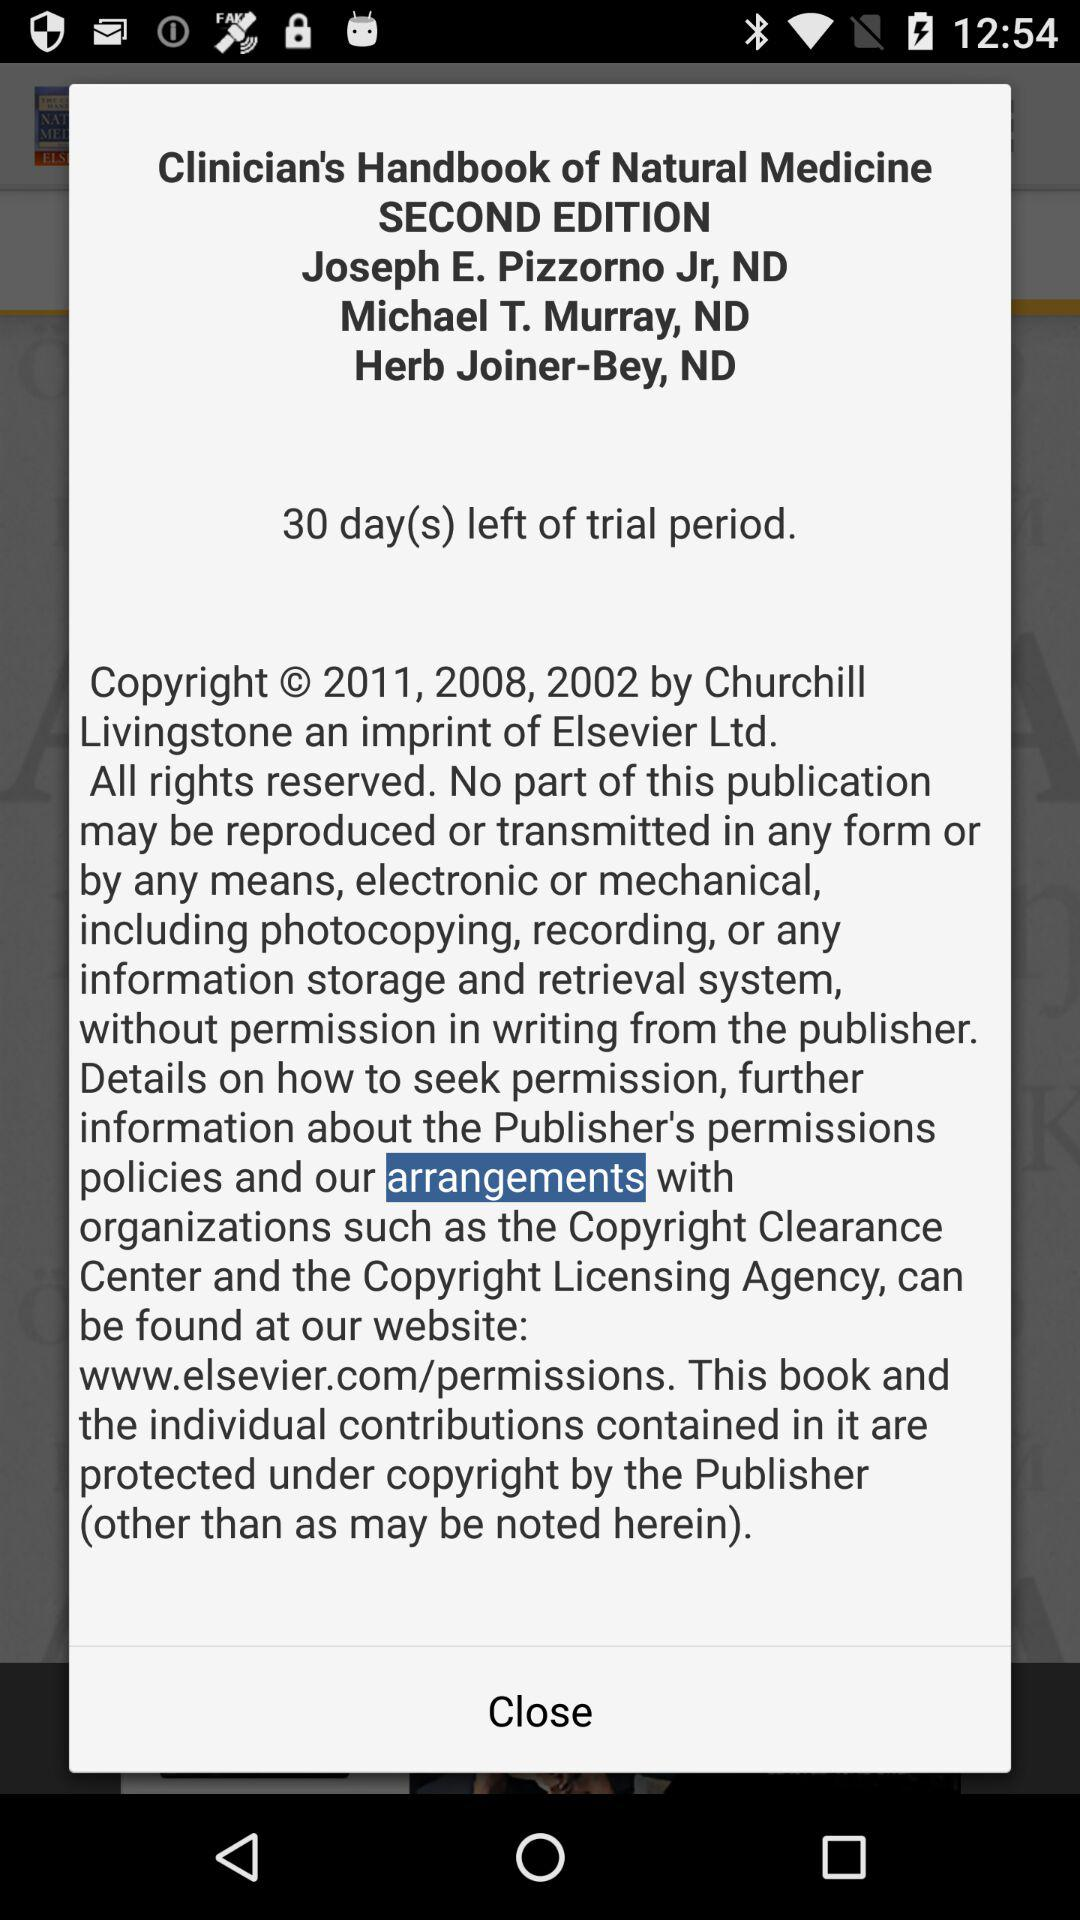Define copyright year?
When the provided information is insufficient, respond with <no answer>. <no answer> 